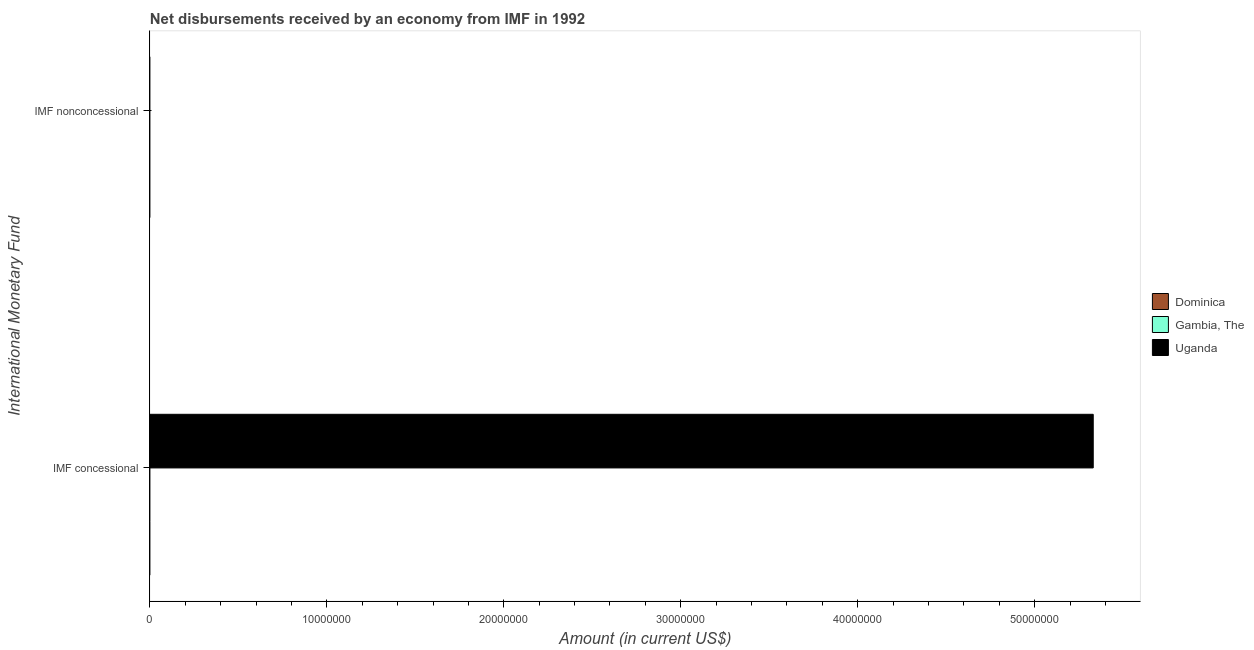How many different coloured bars are there?
Provide a succinct answer. 1. Are the number of bars on each tick of the Y-axis equal?
Offer a terse response. No. What is the label of the 2nd group of bars from the top?
Provide a succinct answer. IMF concessional. What is the net non concessional disbursements from imf in Uganda?
Give a very brief answer. 0. Across all countries, what is the maximum net concessional disbursements from imf?
Keep it short and to the point. 5.33e+07. Across all countries, what is the minimum net concessional disbursements from imf?
Keep it short and to the point. 0. In which country was the net concessional disbursements from imf maximum?
Ensure brevity in your answer.  Uganda. What is the total net concessional disbursements from imf in the graph?
Your response must be concise. 5.33e+07. What is the average net concessional disbursements from imf per country?
Keep it short and to the point. 1.78e+07. In how many countries, is the net concessional disbursements from imf greater than 8000000 US$?
Your answer should be compact. 1. How many bars are there?
Provide a succinct answer. 1. What is the difference between two consecutive major ticks on the X-axis?
Keep it short and to the point. 1.00e+07. Does the graph contain any zero values?
Offer a very short reply. Yes. Does the graph contain grids?
Provide a short and direct response. No. How many legend labels are there?
Keep it short and to the point. 3. What is the title of the graph?
Your answer should be very brief. Net disbursements received by an economy from IMF in 1992. Does "New Zealand" appear as one of the legend labels in the graph?
Your response must be concise. No. What is the label or title of the Y-axis?
Keep it short and to the point. International Monetary Fund. What is the Amount (in current US$) in Dominica in IMF concessional?
Provide a short and direct response. 0. What is the Amount (in current US$) in Uganda in IMF concessional?
Provide a succinct answer. 5.33e+07. What is the Amount (in current US$) in Gambia, The in IMF nonconcessional?
Keep it short and to the point. 0. What is the Amount (in current US$) in Uganda in IMF nonconcessional?
Provide a succinct answer. 0. Across all International Monetary Fund, what is the maximum Amount (in current US$) in Uganda?
Your answer should be very brief. 5.33e+07. Across all International Monetary Fund, what is the minimum Amount (in current US$) of Uganda?
Make the answer very short. 0. What is the total Amount (in current US$) in Dominica in the graph?
Ensure brevity in your answer.  0. What is the total Amount (in current US$) of Gambia, The in the graph?
Provide a short and direct response. 0. What is the total Amount (in current US$) in Uganda in the graph?
Keep it short and to the point. 5.33e+07. What is the average Amount (in current US$) in Uganda per International Monetary Fund?
Your answer should be very brief. 2.67e+07. What is the difference between the highest and the lowest Amount (in current US$) in Uganda?
Your answer should be very brief. 5.33e+07. 